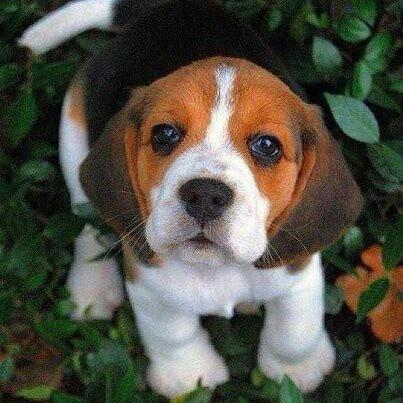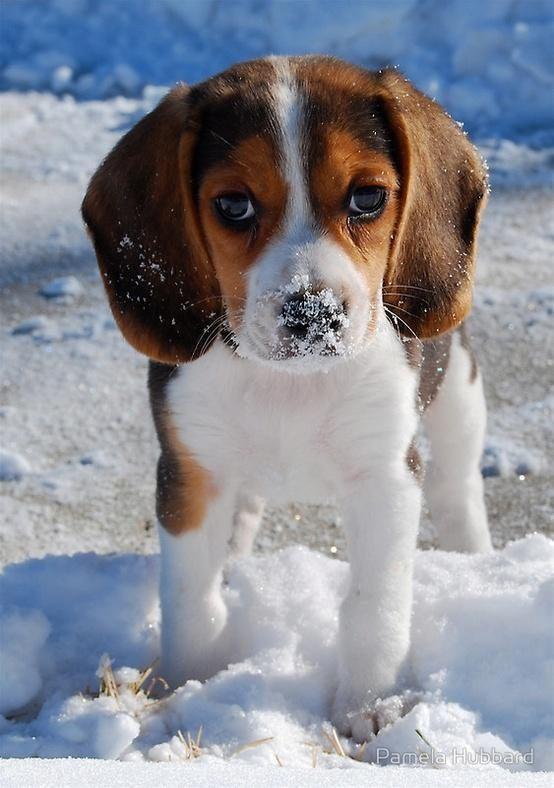The first image is the image on the left, the second image is the image on the right. Assess this claim about the two images: "Exactly one dog in the right image is standing.". Correct or not? Answer yes or no. Yes. The first image is the image on the left, the second image is the image on the right. Assess this claim about the two images: "Each image contains one dog, and one image shows a sitting puppy while the other shows a tri-color beagle wearing something around its neck.". Correct or not? Answer yes or no. No. 